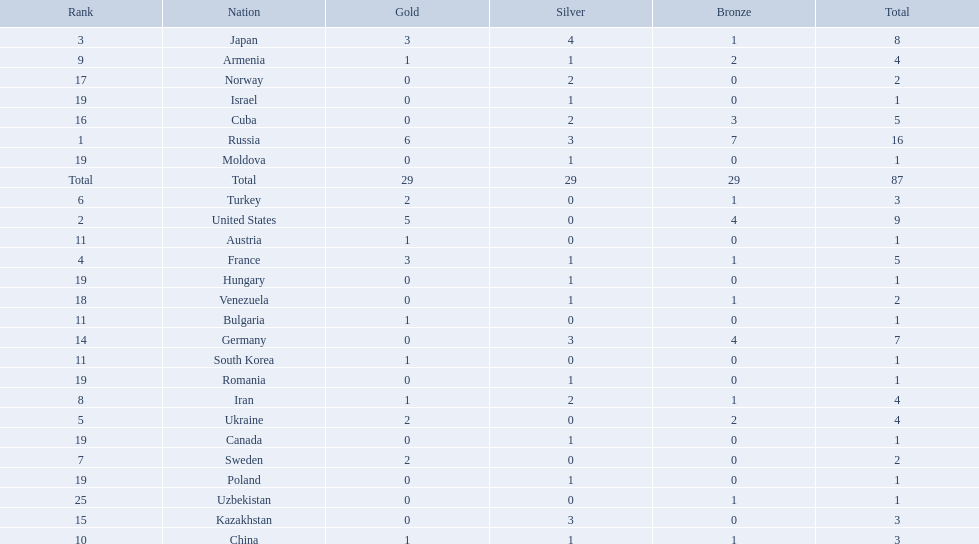I'm looking to parse the entire table for insights. Could you assist me with that? {'header': ['Rank', 'Nation', 'Gold', 'Silver', 'Bronze', 'Total'], 'rows': [['3', 'Japan', '3', '4', '1', '8'], ['9', 'Armenia', '1', '1', '2', '4'], ['17', 'Norway', '0', '2', '0', '2'], ['19', 'Israel', '0', '1', '0', '1'], ['16', 'Cuba', '0', '2', '3', '5'], ['1', 'Russia', '6', '3', '7', '16'], ['19', 'Moldova', '0', '1', '0', '1'], ['Total', 'Total', '29', '29', '29', '87'], ['6', 'Turkey', '2', '0', '1', '3'], ['2', 'United States', '5', '0', '4', '9'], ['11', 'Austria', '1', '0', '0', '1'], ['4', 'France', '3', '1', '1', '5'], ['19', 'Hungary', '0', '1', '0', '1'], ['18', 'Venezuela', '0', '1', '1', '2'], ['11', 'Bulgaria', '1', '0', '0', '1'], ['14', 'Germany', '0', '3', '4', '7'], ['11', 'South Korea', '1', '0', '0', '1'], ['19', 'Romania', '0', '1', '0', '1'], ['8', 'Iran', '1', '2', '1', '4'], ['5', 'Ukraine', '2', '0', '2', '4'], ['19', 'Canada', '0', '1', '0', '1'], ['7', 'Sweden', '2', '0', '0', '2'], ['19', 'Poland', '0', '1', '0', '1'], ['25', 'Uzbekistan', '0', '0', '1', '1'], ['15', 'Kazakhstan', '0', '3', '0', '3'], ['10', 'China', '1', '1', '1', '3']]} Which nations are there? Russia, 6, United States, 5, Japan, 3, France, 3, Ukraine, 2, Turkey, 2, Sweden, 2, Iran, 1, Armenia, 1, China, 1, Austria, 1, Bulgaria, 1, South Korea, 1, Germany, 0, Kazakhstan, 0, Cuba, 0, Norway, 0, Venezuela, 0, Canada, 0, Hungary, 0, Israel, 0, Moldova, 0, Poland, 0, Romania, 0, Uzbekistan, 0. Which nations won gold? Russia, 6, United States, 5, Japan, 3, France, 3, Ukraine, 2, Turkey, 2, Sweden, 2, Iran, 1, Armenia, 1, China, 1, Austria, 1, Bulgaria, 1, South Korea, 1. How many golds did united states win? United States, 5. Which country has more than 5 gold medals? Russia, 6. What country is it? Russia. What nations have one gold medal? Iran, Armenia, China, Austria, Bulgaria, South Korea. Of these, which nations have zero silver medals? Austria, Bulgaria, South Korea. Of these, which nations also have zero bronze medals? Austria. 